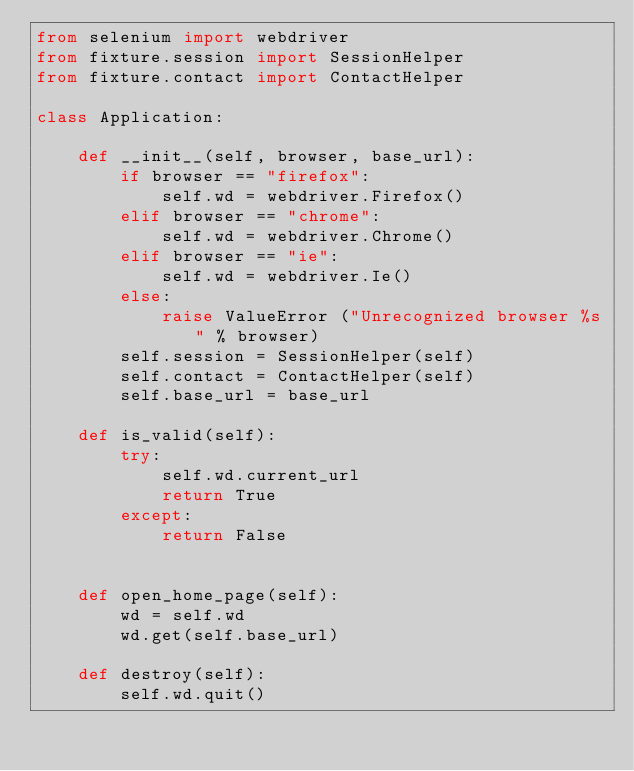Convert code to text. <code><loc_0><loc_0><loc_500><loc_500><_Python_>from selenium import webdriver
from fixture.session import SessionHelper
from fixture.contact import ContactHelper

class Application:

    def __init__(self, browser, base_url):
        if browser == "firefox":
            self.wd = webdriver.Firefox()
        elif browser == "chrome":
            self.wd = webdriver.Chrome()
        elif browser == "ie":
            self.wd = webdriver.Ie()
        else:
            raise ValueError ("Unrecognized browser %s" % browser)
        self.session = SessionHelper(self)
        self.contact = ContactHelper(self)
        self.base_url = base_url

    def is_valid(self):
        try:
            self.wd.current_url
            return True
        except:
            return False


    def open_home_page(self):
        wd = self.wd
        wd.get(self.base_url)

    def destroy(self):
        self.wd.quit()</code> 